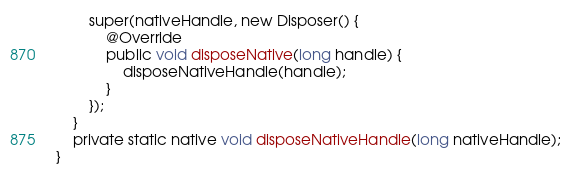<code> <loc_0><loc_0><loc_500><loc_500><_Java_>        super(nativeHandle, new Disposer() {
            @Override
            public void disposeNative(long handle) {
                disposeNativeHandle(handle);
            }
        });
    }
    private static native void disposeNativeHandle(long nativeHandle);
}
</code> 